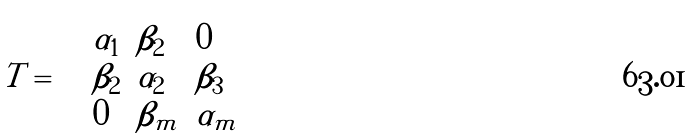<formula> <loc_0><loc_0><loc_500><loc_500>T = { \left ( \begin{array} { l l l l l l } { \alpha _ { 1 } } & { \beta _ { 2 } } & { 0 } \\ { \beta _ { 2 } } & { \alpha _ { 2 } } & { \beta _ { 3 } } \\ { 0 } & { \beta _ { m } } & { \alpha _ { m } } \end{array} \right ) }</formula> 